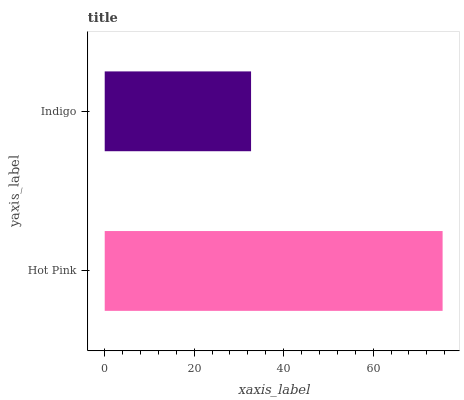Is Indigo the minimum?
Answer yes or no. Yes. Is Hot Pink the maximum?
Answer yes or no. Yes. Is Indigo the maximum?
Answer yes or no. No. Is Hot Pink greater than Indigo?
Answer yes or no. Yes. Is Indigo less than Hot Pink?
Answer yes or no. Yes. Is Indigo greater than Hot Pink?
Answer yes or no. No. Is Hot Pink less than Indigo?
Answer yes or no. No. Is Hot Pink the high median?
Answer yes or no. Yes. Is Indigo the low median?
Answer yes or no. Yes. Is Indigo the high median?
Answer yes or no. No. Is Hot Pink the low median?
Answer yes or no. No. 